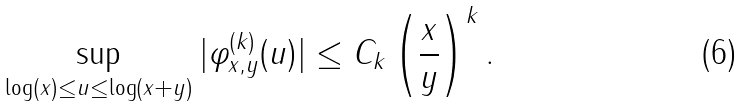<formula> <loc_0><loc_0><loc_500><loc_500>\sup _ { \log ( x ) \leq u \leq \log ( x + y ) } | \varphi ^ { ( k ) } _ { x , y } ( u ) | \leq C _ { k } \left ( \frac { x } { y } \right ) ^ { k } .</formula> 